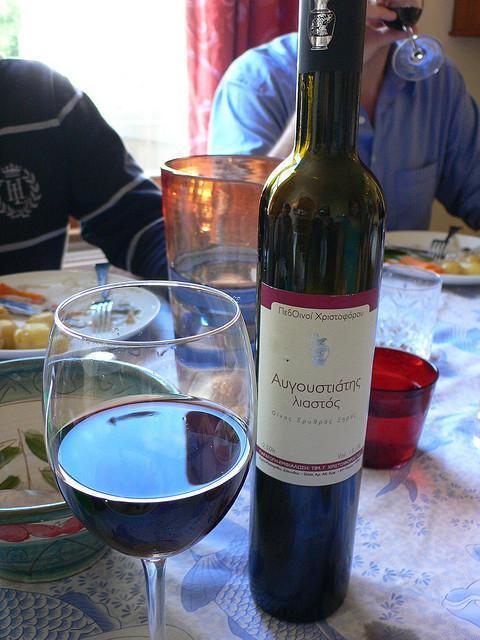How many wine glasses are visible?
Give a very brief answer. 2. How many cups are visible?
Give a very brief answer. 3. How many people are visible?
Give a very brief answer. 2. 